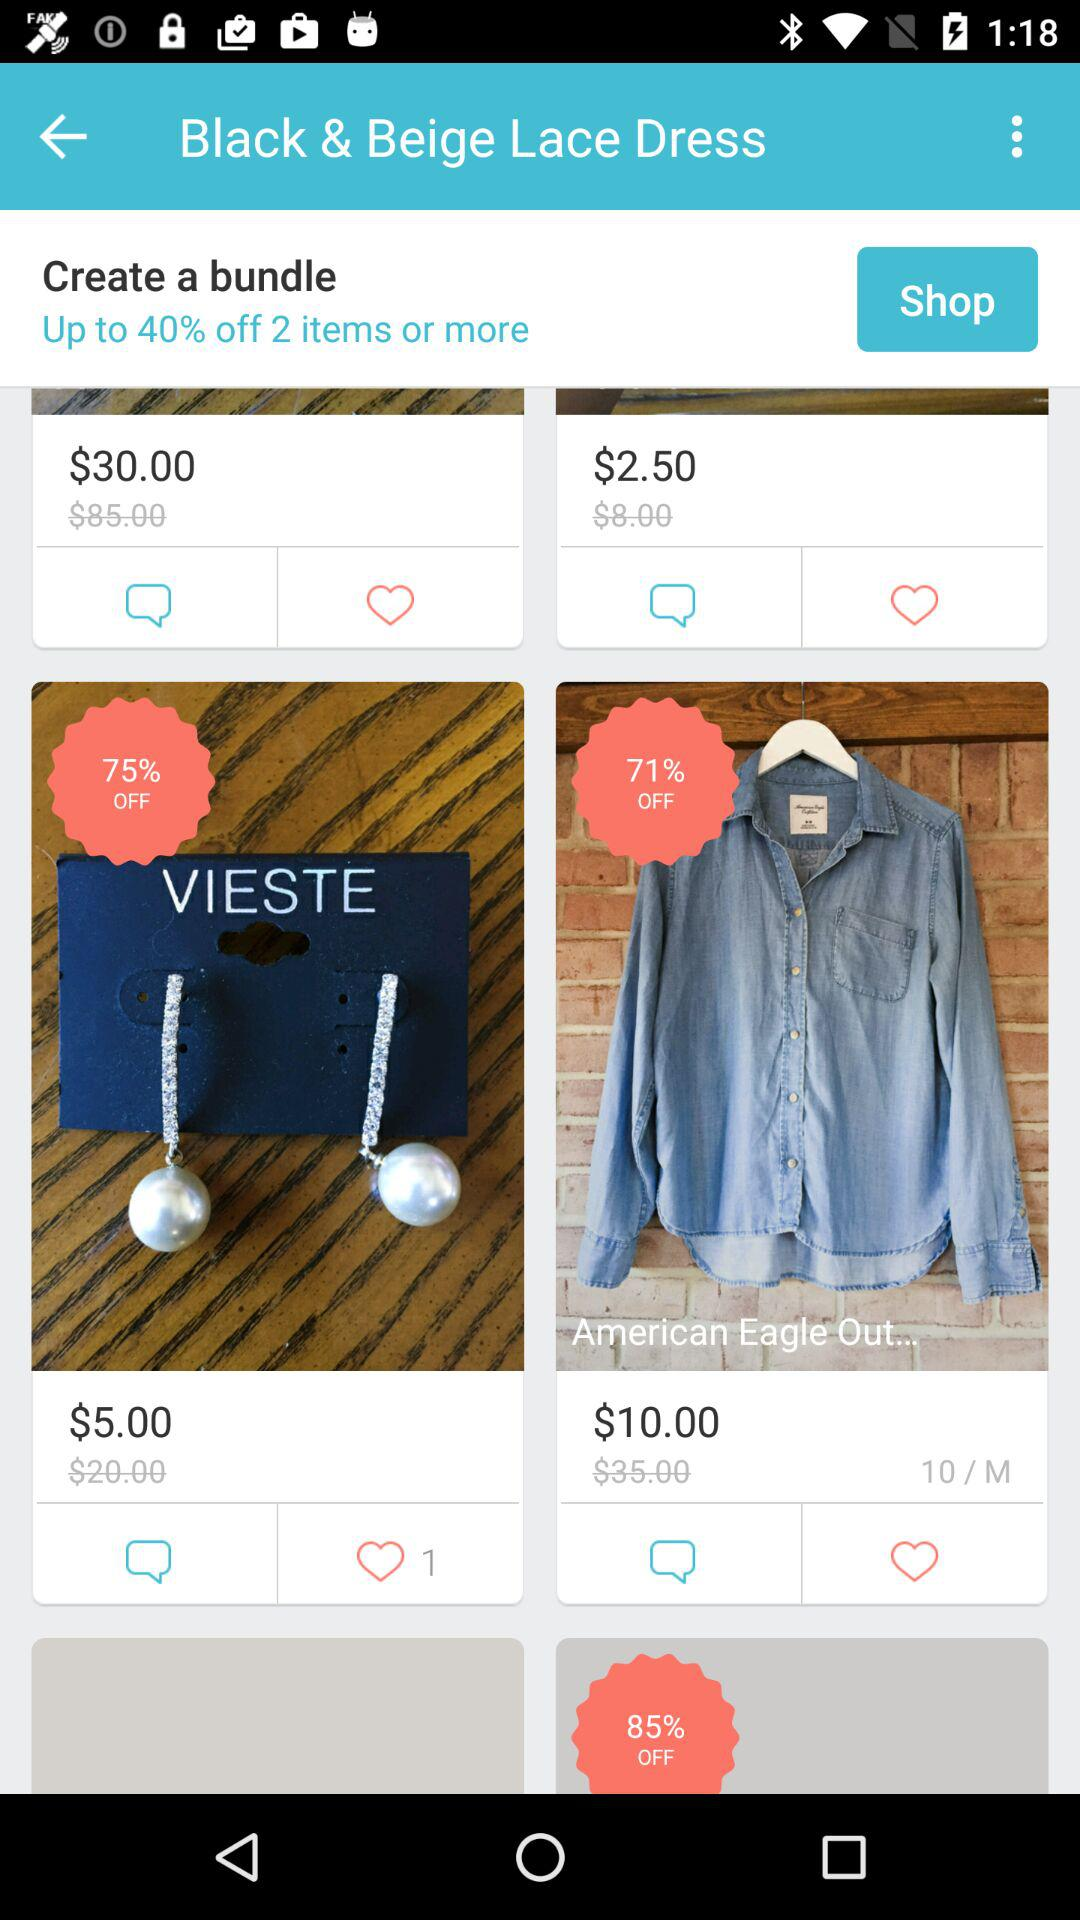How many likes does the "VIESTE" item get? The "VIESTE" item got 1 like. 